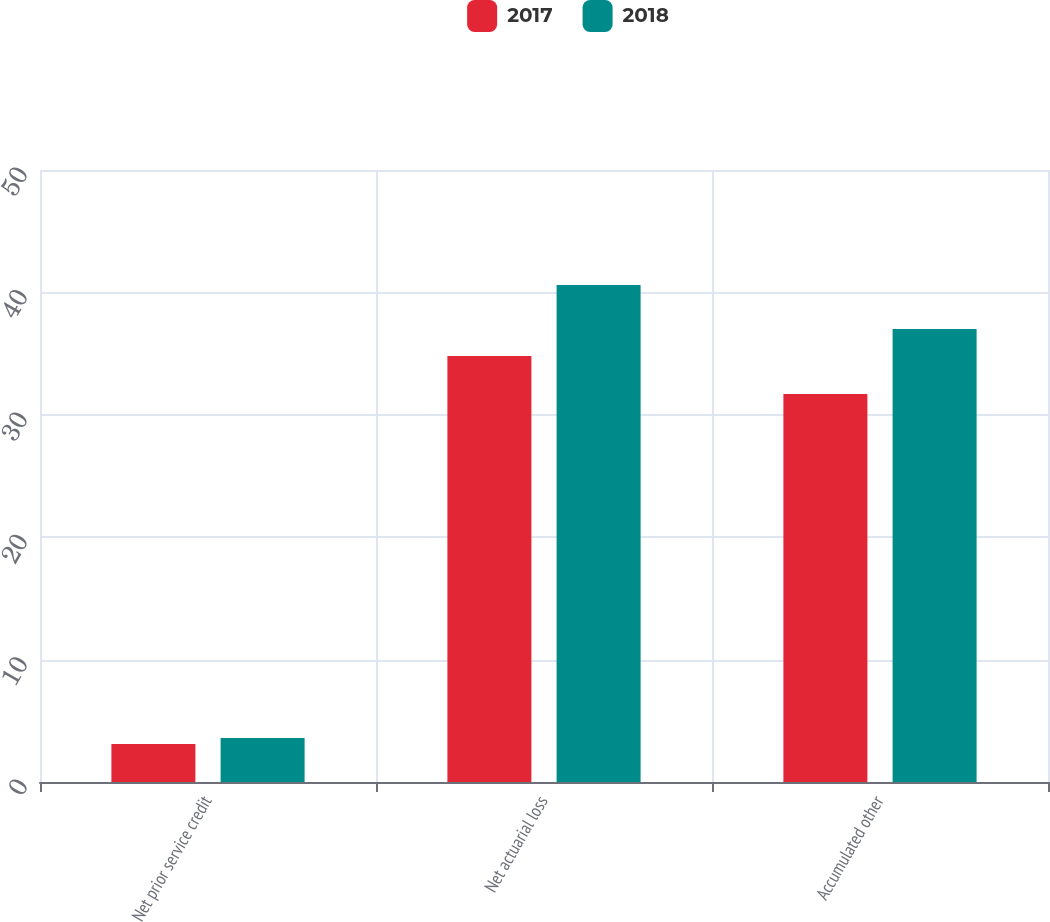Convert chart to OTSL. <chart><loc_0><loc_0><loc_500><loc_500><stacked_bar_chart><ecel><fcel>Net prior service credit<fcel>Net actuarial loss<fcel>Accumulated other<nl><fcel>2017<fcel>3.1<fcel>34.8<fcel>31.7<nl><fcel>2018<fcel>3.6<fcel>40.6<fcel>37<nl></chart> 